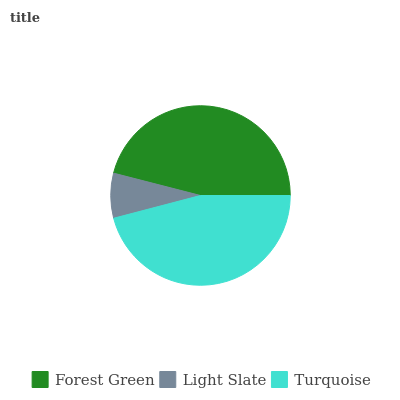Is Light Slate the minimum?
Answer yes or no. Yes. Is Forest Green the maximum?
Answer yes or no. Yes. Is Turquoise the minimum?
Answer yes or no. No. Is Turquoise the maximum?
Answer yes or no. No. Is Turquoise greater than Light Slate?
Answer yes or no. Yes. Is Light Slate less than Turquoise?
Answer yes or no. Yes. Is Light Slate greater than Turquoise?
Answer yes or no. No. Is Turquoise less than Light Slate?
Answer yes or no. No. Is Turquoise the high median?
Answer yes or no. Yes. Is Turquoise the low median?
Answer yes or no. Yes. Is Light Slate the high median?
Answer yes or no. No. Is Forest Green the low median?
Answer yes or no. No. 